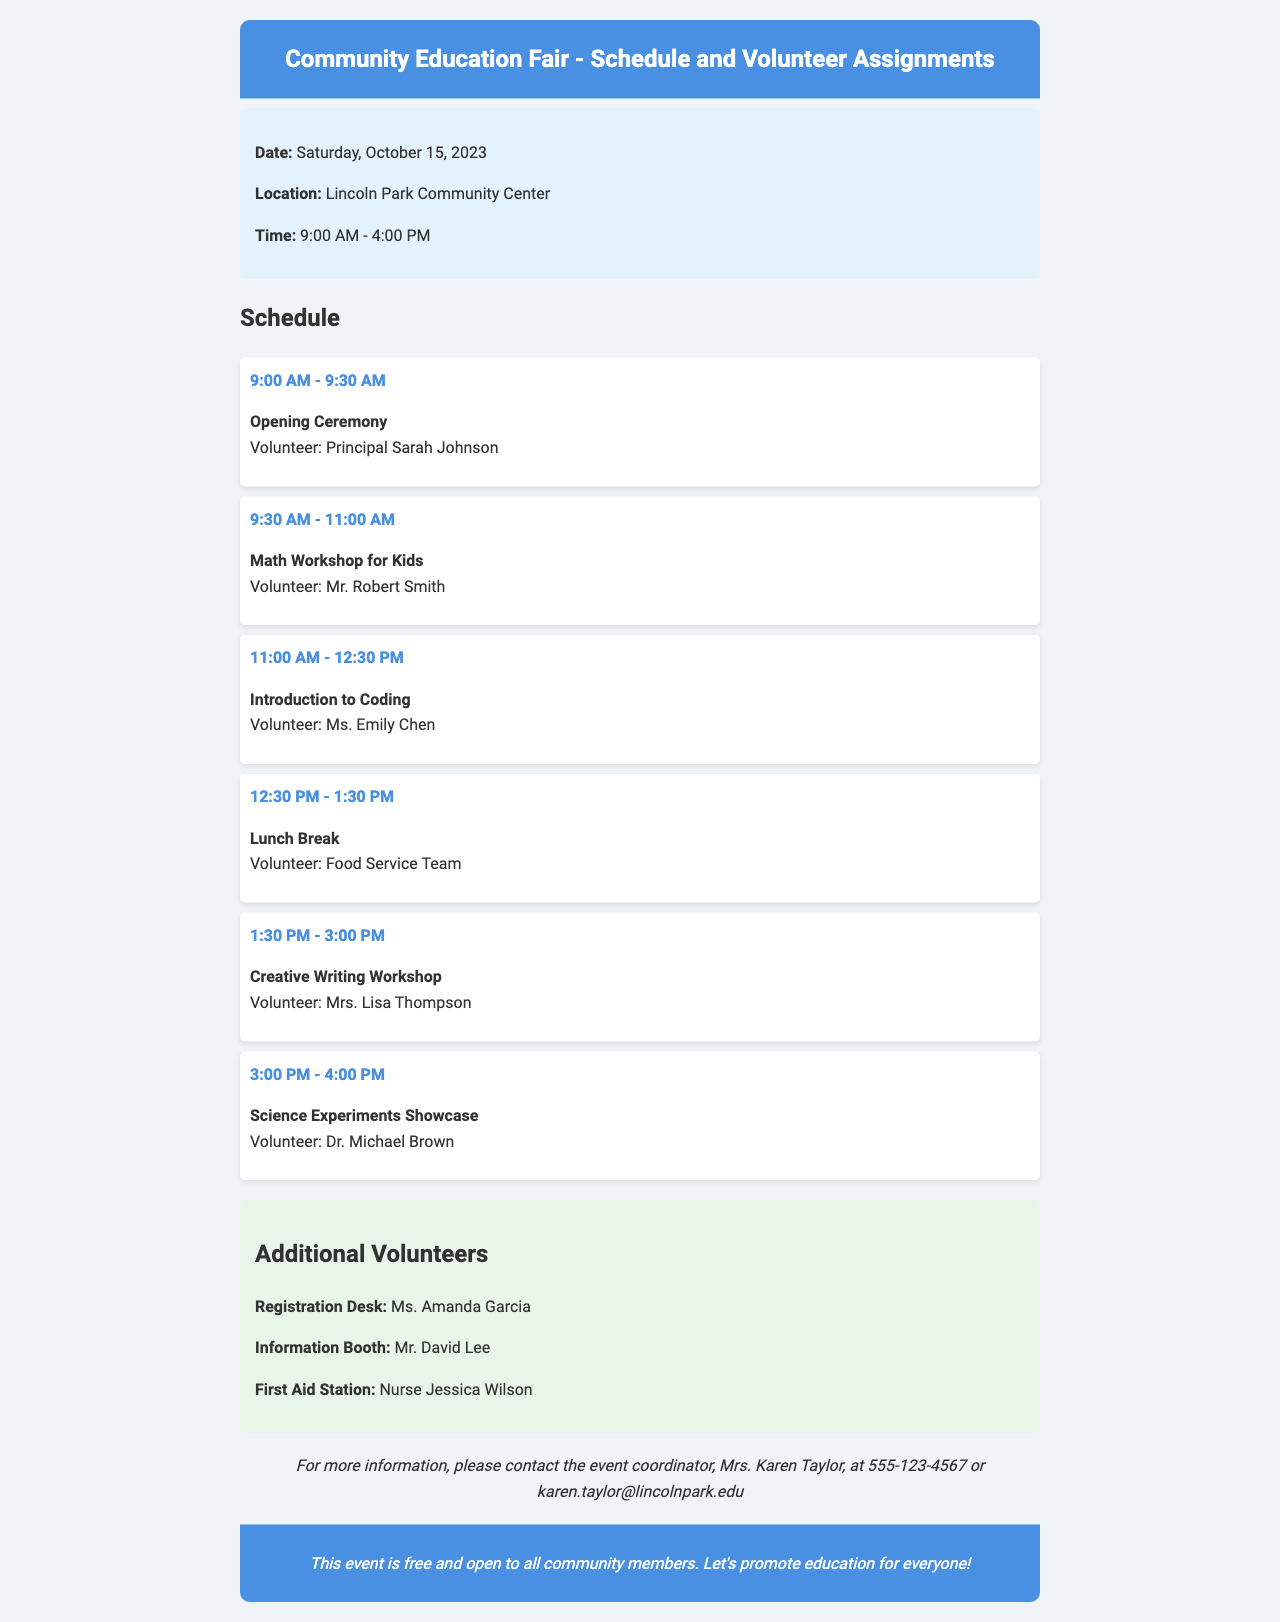What is the date of the event? The date of the event is explicitly stated in the document.
Answer: Saturday, October 15, 2023 Who is volunteering for the Opening Ceremony? The document lists the volunteer for each event, including the Opening Ceremony.
Answer: Principal Sarah Johnson What time does the Creative Writing Workshop start? The schedule includes start times for all events, and the specific time for the Creative Writing Workshop can be found there.
Answer: 1:30 PM How long is the Lunch Break? The document specifies the duration of the Lunch Break under the schedule section.
Answer: 1 hour Who is responsible for the First Aid Station? Additional volunteers are listed along with their assignments in the document.
Answer: Nurse Jessica Wilson How many events are listed in the schedule? The document lays out a specific number of events in the schedule section.
Answer: 6 What is the location of the Community Education Fair? The location details are provided in the information section of the document.
Answer: Lincoln Park Community Center What volunteer role is assigned to Ms. Amanda Garcia? The document states specific responsibilities for additional volunteers and identifies Ms. Amanda Garcia's role.
Answer: Registration Desk What is the ending time of the fair? The document indicates the end time in the information section and also in the schedule.
Answer: 4:00 PM 